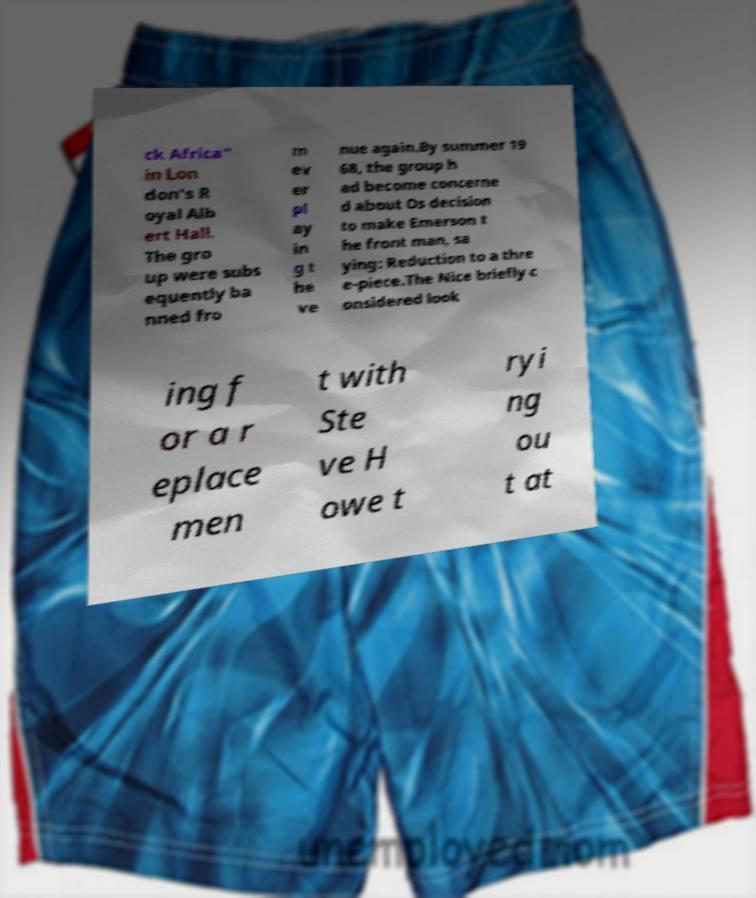For documentation purposes, I need the text within this image transcribed. Could you provide that? ck Africa" in Lon don's R oyal Alb ert Hall. The gro up were subs equently ba nned fro m ev er pl ay in g t he ve nue again.By summer 19 68, the group h ad become concerne d about Os decision to make Emerson t he front man, sa ying: Reduction to a thre e-piece.The Nice briefly c onsidered look ing f or a r eplace men t with Ste ve H owe t ryi ng ou t at 